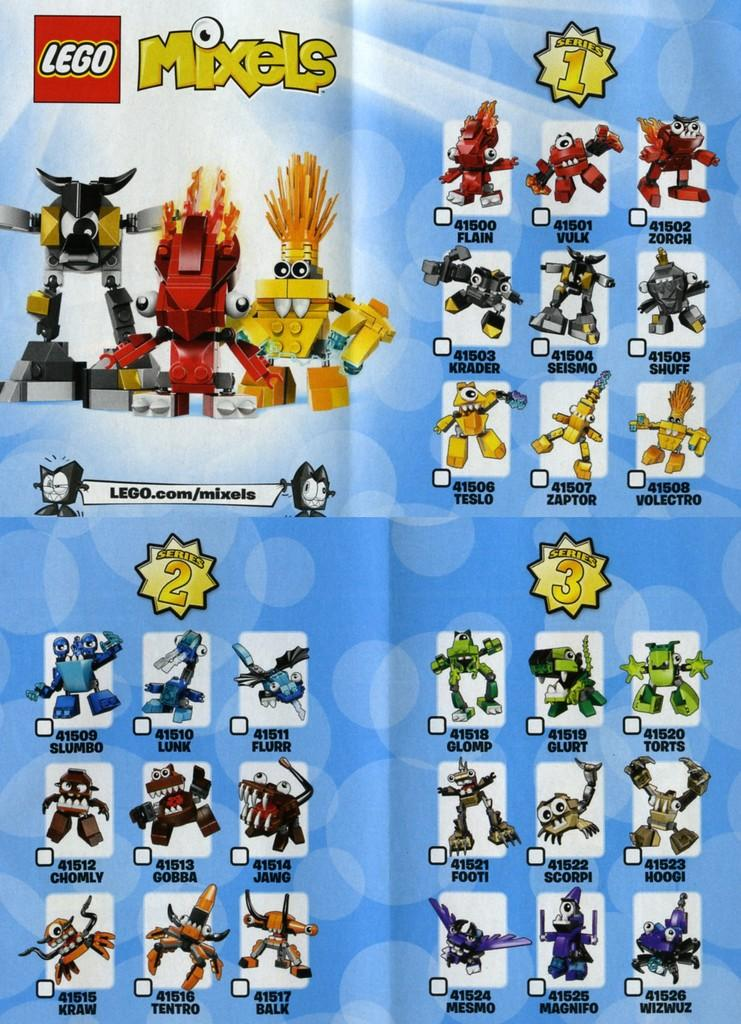What is featured on the poster in the image? The poster contains pictures of toys. Are there any words or numbers on the poster? Yes, words and numbers are written on the poster. What colors are used for the poster? The poster is white and blue in color. Can you see any veins in the image? There are no veins visible in the image; it features a poster with pictures of toys. What time is displayed on the clock in the image? There is no clock present in the image. 